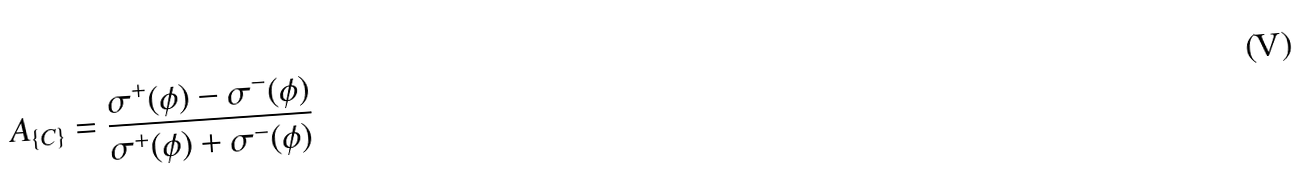Convert formula to latex. <formula><loc_0><loc_0><loc_500><loc_500>A _ { \{ C \} } = \frac { \sigma ^ { + } ( \phi ) - \sigma ^ { - } ( \phi ) } { \sigma ^ { + } ( \phi ) + \sigma ^ { - } ( \phi ) }</formula> 